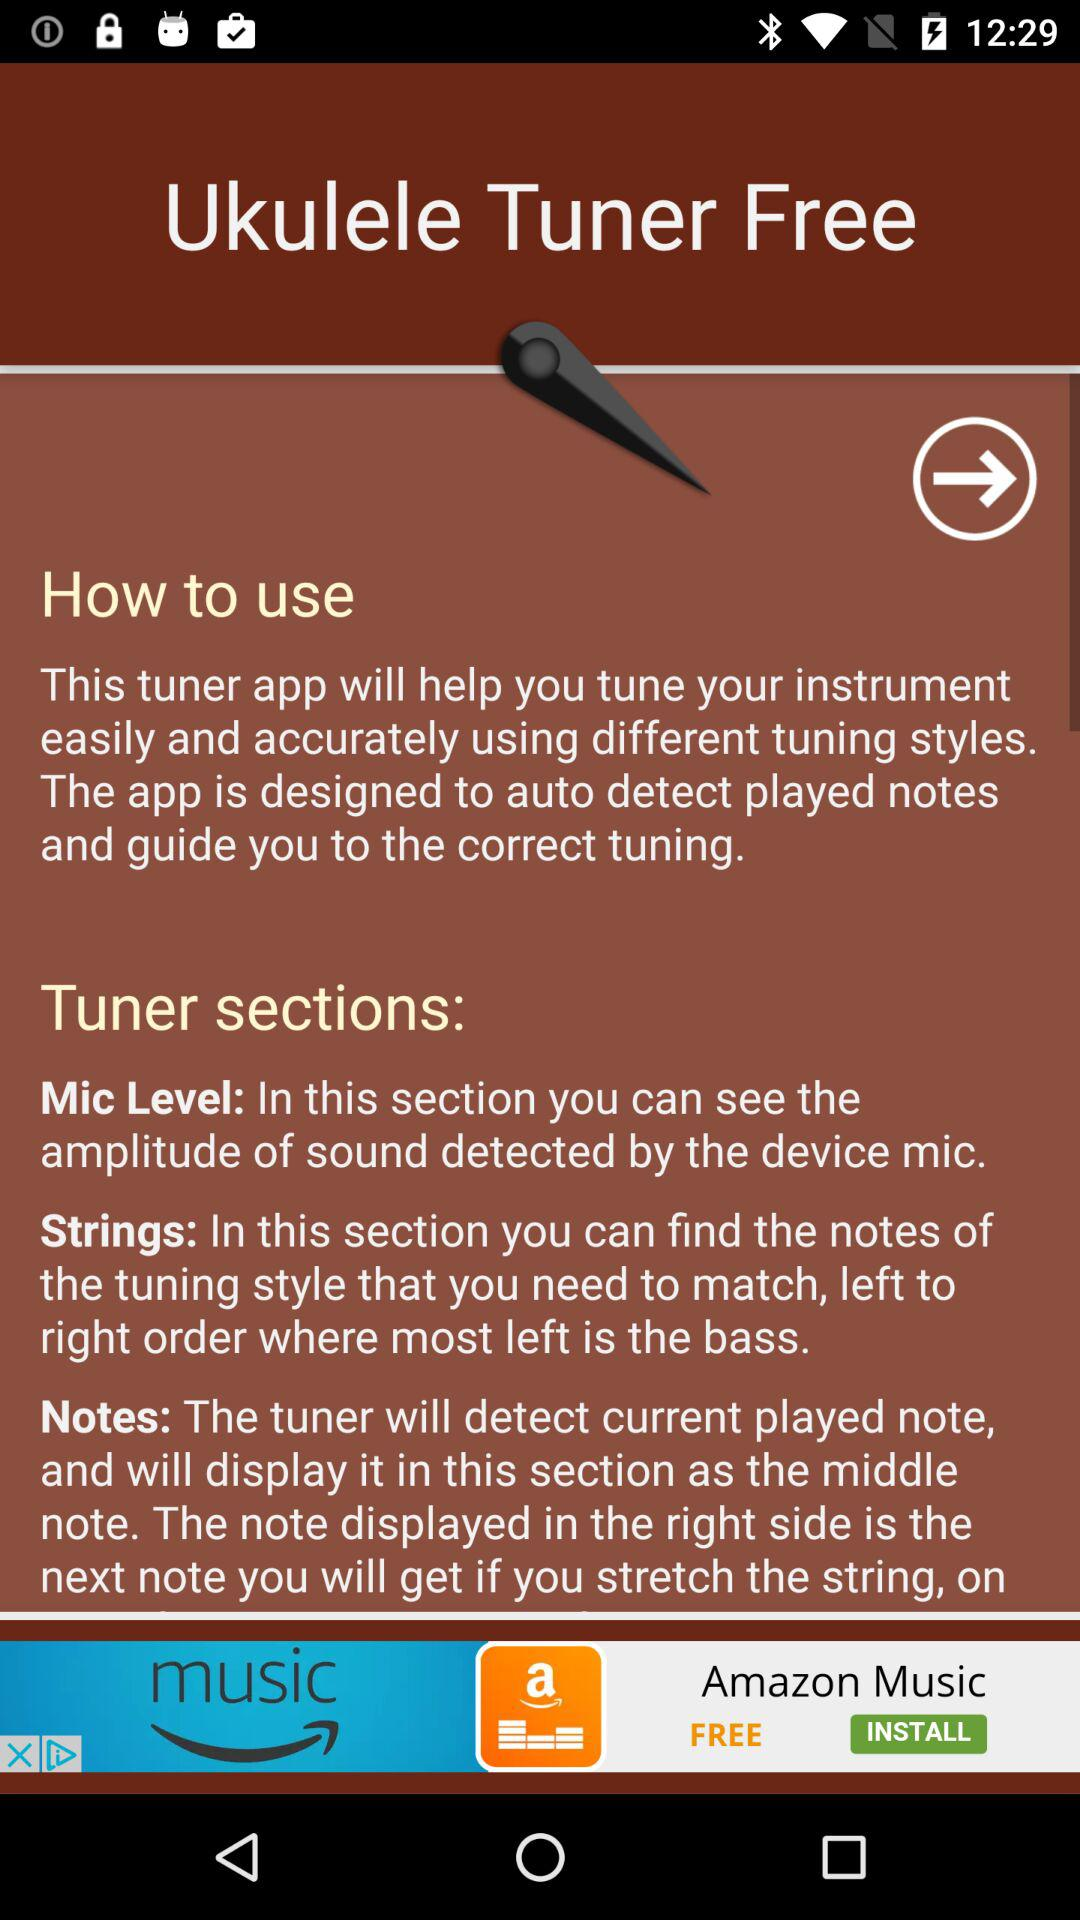What is the name of the application? The name of the application is "Ukulele Tuner Free". 